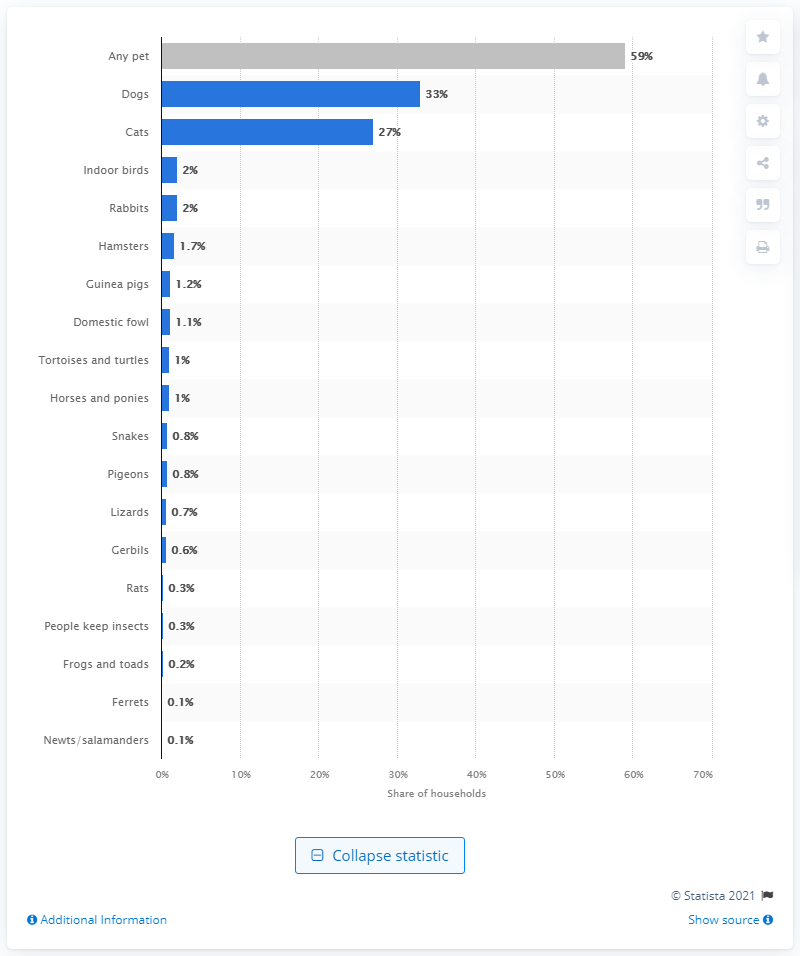Point out several critical features in this image. In 2020/21, approximately 33% of households in the UK reported owning a dog, according to data. 